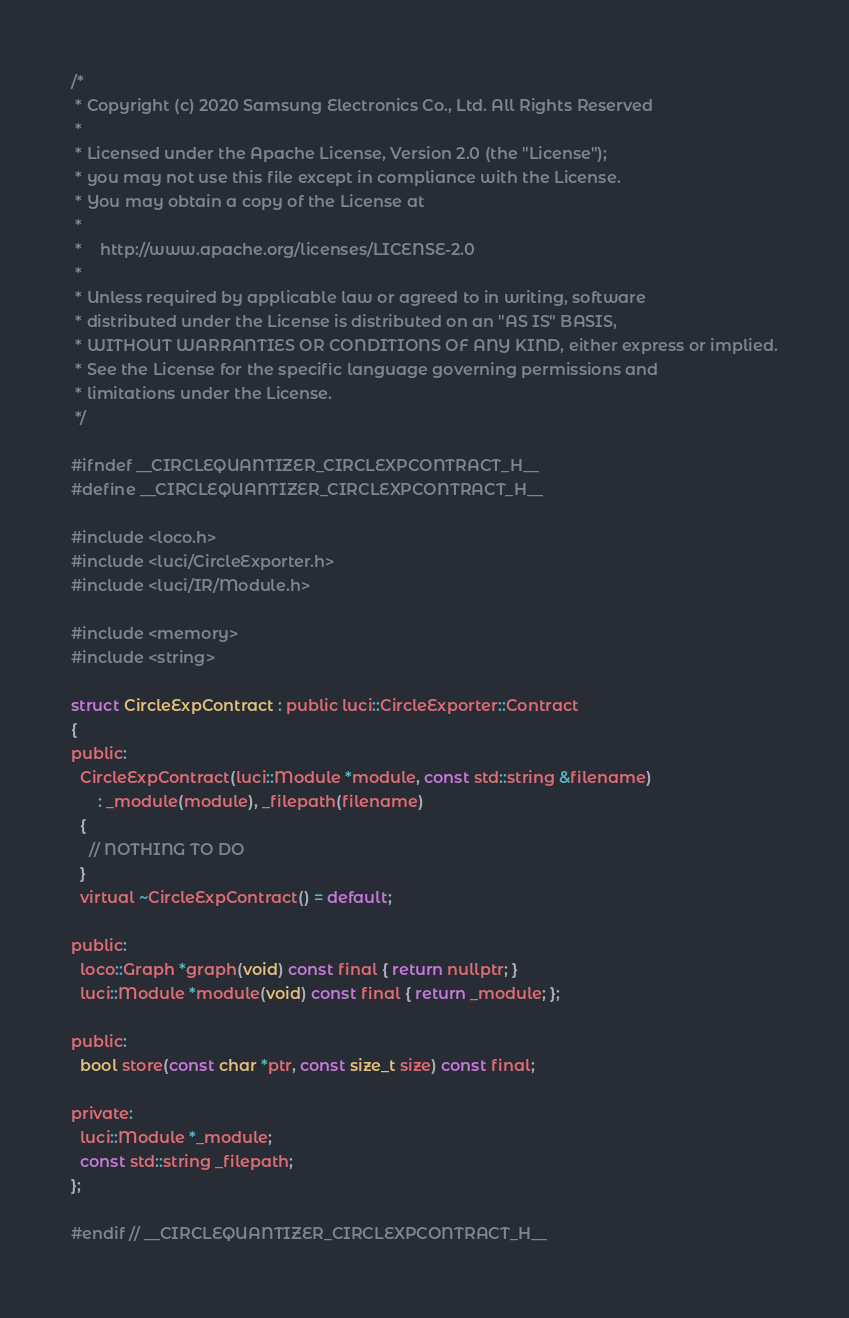Convert code to text. <code><loc_0><loc_0><loc_500><loc_500><_C_>/*
 * Copyright (c) 2020 Samsung Electronics Co., Ltd. All Rights Reserved
 *
 * Licensed under the Apache License, Version 2.0 (the "License");
 * you may not use this file except in compliance with the License.
 * You may obtain a copy of the License at
 *
 *    http://www.apache.org/licenses/LICENSE-2.0
 *
 * Unless required by applicable law or agreed to in writing, software
 * distributed under the License is distributed on an "AS IS" BASIS,
 * WITHOUT WARRANTIES OR CONDITIONS OF ANY KIND, either express or implied.
 * See the License for the specific language governing permissions and
 * limitations under the License.
 */

#ifndef __CIRCLEQUANTIZER_CIRCLEXPCONTRACT_H__
#define __CIRCLEQUANTIZER_CIRCLEXPCONTRACT_H__

#include <loco.h>
#include <luci/CircleExporter.h>
#include <luci/IR/Module.h>

#include <memory>
#include <string>

struct CircleExpContract : public luci::CircleExporter::Contract
{
public:
  CircleExpContract(luci::Module *module, const std::string &filename)
      : _module(module), _filepath(filename)
  {
    // NOTHING TO DO
  }
  virtual ~CircleExpContract() = default;

public:
  loco::Graph *graph(void) const final { return nullptr; }
  luci::Module *module(void) const final { return _module; };

public:
  bool store(const char *ptr, const size_t size) const final;

private:
  luci::Module *_module;
  const std::string _filepath;
};

#endif // __CIRCLEQUANTIZER_CIRCLEXPCONTRACT_H__
</code> 